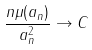<formula> <loc_0><loc_0><loc_500><loc_500>\frac { n \mu ( a _ { n } ) } { a _ { n } ^ { 2 } } \to C</formula> 